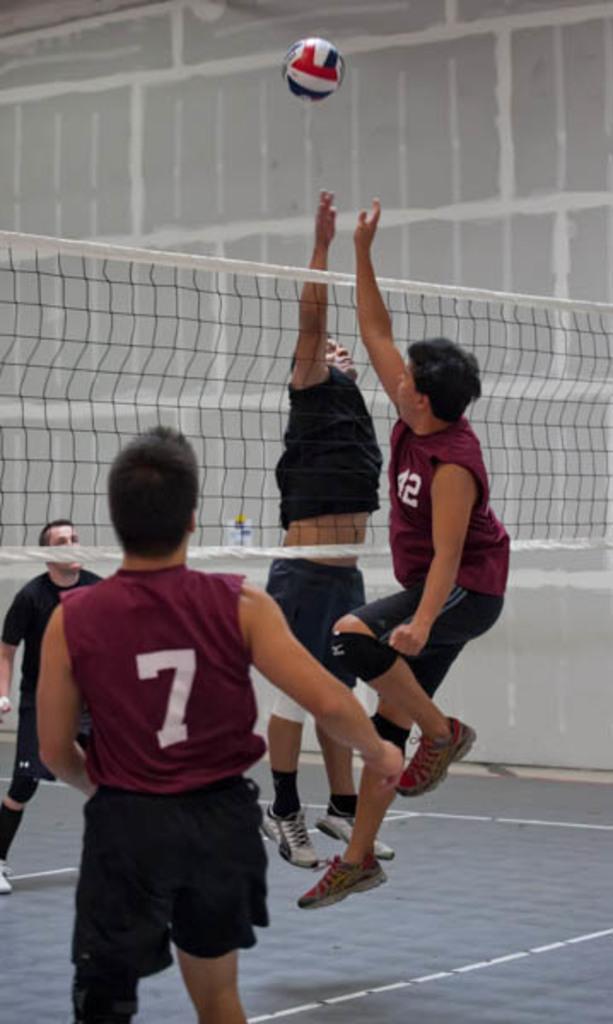Please provide a concise description of this image. In this picture, we see two men are jumping. In front of them, we see a net. On the left side, we see two men are standing. Four of them are playing the volleyball. In the background, we see a wall. This picture might be clicked in the volleyball court. 